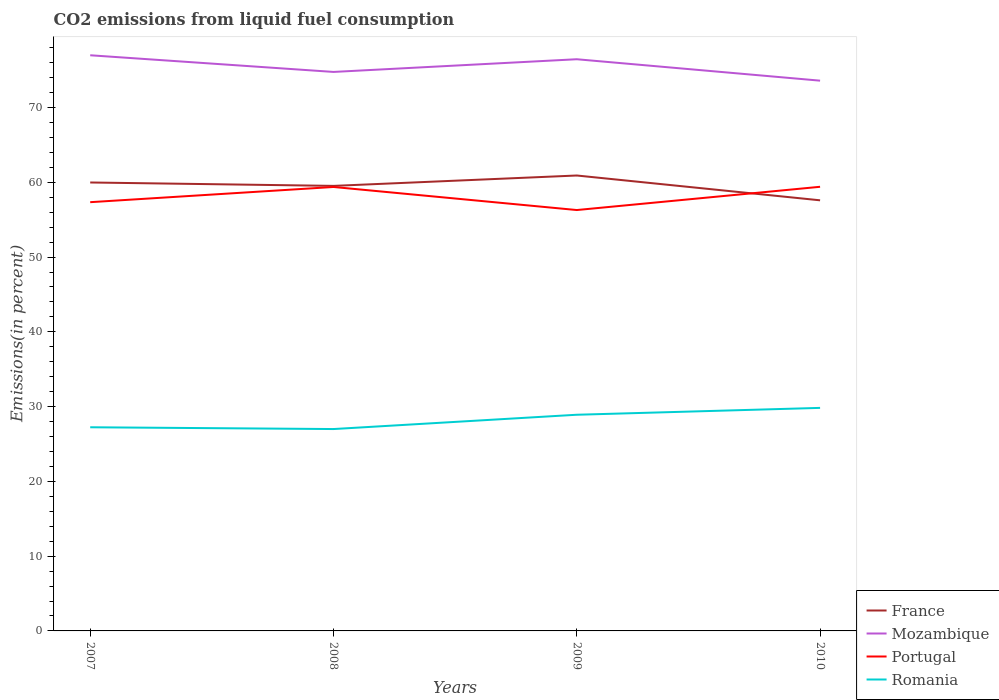How many different coloured lines are there?
Your answer should be compact. 4. Across all years, what is the maximum total CO2 emitted in Portugal?
Provide a short and direct response. 56.29. What is the total total CO2 emitted in Portugal in the graph?
Keep it short and to the point. -2.06. What is the difference between the highest and the second highest total CO2 emitted in France?
Your answer should be very brief. 3.32. What is the difference between the highest and the lowest total CO2 emitted in Portugal?
Keep it short and to the point. 2. Is the total CO2 emitted in Portugal strictly greater than the total CO2 emitted in Romania over the years?
Your answer should be compact. No. How many lines are there?
Your response must be concise. 4. What is the difference between two consecutive major ticks on the Y-axis?
Give a very brief answer. 10. Does the graph contain grids?
Make the answer very short. No. How are the legend labels stacked?
Provide a short and direct response. Vertical. What is the title of the graph?
Offer a very short reply. CO2 emissions from liquid fuel consumption. What is the label or title of the X-axis?
Offer a terse response. Years. What is the label or title of the Y-axis?
Make the answer very short. Emissions(in percent). What is the Emissions(in percent) in France in 2007?
Your answer should be compact. 59.98. What is the Emissions(in percent) of Mozambique in 2007?
Give a very brief answer. 76.99. What is the Emissions(in percent) in Portugal in 2007?
Ensure brevity in your answer.  57.34. What is the Emissions(in percent) in Romania in 2007?
Ensure brevity in your answer.  27.24. What is the Emissions(in percent) in France in 2008?
Your response must be concise. 59.52. What is the Emissions(in percent) of Mozambique in 2008?
Offer a terse response. 74.76. What is the Emissions(in percent) in Portugal in 2008?
Provide a short and direct response. 59.38. What is the Emissions(in percent) of Romania in 2008?
Offer a terse response. 27. What is the Emissions(in percent) of France in 2009?
Make the answer very short. 60.91. What is the Emissions(in percent) of Mozambique in 2009?
Provide a short and direct response. 76.46. What is the Emissions(in percent) in Portugal in 2009?
Keep it short and to the point. 56.29. What is the Emissions(in percent) of Romania in 2009?
Provide a succinct answer. 28.91. What is the Emissions(in percent) in France in 2010?
Provide a succinct answer. 57.59. What is the Emissions(in percent) of Mozambique in 2010?
Offer a very short reply. 73.6. What is the Emissions(in percent) in Portugal in 2010?
Make the answer very short. 59.4. What is the Emissions(in percent) in Romania in 2010?
Provide a short and direct response. 29.83. Across all years, what is the maximum Emissions(in percent) in France?
Provide a succinct answer. 60.91. Across all years, what is the maximum Emissions(in percent) in Mozambique?
Your answer should be compact. 76.99. Across all years, what is the maximum Emissions(in percent) in Portugal?
Ensure brevity in your answer.  59.4. Across all years, what is the maximum Emissions(in percent) in Romania?
Offer a very short reply. 29.83. Across all years, what is the minimum Emissions(in percent) of France?
Give a very brief answer. 57.59. Across all years, what is the minimum Emissions(in percent) of Mozambique?
Your response must be concise. 73.6. Across all years, what is the minimum Emissions(in percent) of Portugal?
Your response must be concise. 56.29. Across all years, what is the minimum Emissions(in percent) in Romania?
Keep it short and to the point. 27. What is the total Emissions(in percent) of France in the graph?
Provide a succinct answer. 238.01. What is the total Emissions(in percent) of Mozambique in the graph?
Ensure brevity in your answer.  301.82. What is the total Emissions(in percent) in Portugal in the graph?
Your response must be concise. 232.42. What is the total Emissions(in percent) of Romania in the graph?
Your answer should be compact. 112.98. What is the difference between the Emissions(in percent) in France in 2007 and that in 2008?
Your response must be concise. 0.45. What is the difference between the Emissions(in percent) of Mozambique in 2007 and that in 2008?
Provide a short and direct response. 2.23. What is the difference between the Emissions(in percent) in Portugal in 2007 and that in 2008?
Keep it short and to the point. -2.03. What is the difference between the Emissions(in percent) of Romania in 2007 and that in 2008?
Offer a very short reply. 0.24. What is the difference between the Emissions(in percent) of France in 2007 and that in 2009?
Your response must be concise. -0.93. What is the difference between the Emissions(in percent) of Mozambique in 2007 and that in 2009?
Your response must be concise. 0.53. What is the difference between the Emissions(in percent) of Portugal in 2007 and that in 2009?
Provide a succinct answer. 1.05. What is the difference between the Emissions(in percent) in Romania in 2007 and that in 2009?
Provide a succinct answer. -1.67. What is the difference between the Emissions(in percent) of France in 2007 and that in 2010?
Your response must be concise. 2.38. What is the difference between the Emissions(in percent) of Mozambique in 2007 and that in 2010?
Keep it short and to the point. 3.4. What is the difference between the Emissions(in percent) of Portugal in 2007 and that in 2010?
Provide a succinct answer. -2.06. What is the difference between the Emissions(in percent) in Romania in 2007 and that in 2010?
Your response must be concise. -2.59. What is the difference between the Emissions(in percent) in France in 2008 and that in 2009?
Ensure brevity in your answer.  -1.39. What is the difference between the Emissions(in percent) in Mozambique in 2008 and that in 2009?
Ensure brevity in your answer.  -1.7. What is the difference between the Emissions(in percent) of Portugal in 2008 and that in 2009?
Give a very brief answer. 3.09. What is the difference between the Emissions(in percent) in Romania in 2008 and that in 2009?
Provide a short and direct response. -1.91. What is the difference between the Emissions(in percent) of France in 2008 and that in 2010?
Ensure brevity in your answer.  1.93. What is the difference between the Emissions(in percent) in Mozambique in 2008 and that in 2010?
Make the answer very short. 1.17. What is the difference between the Emissions(in percent) of Portugal in 2008 and that in 2010?
Give a very brief answer. -0.02. What is the difference between the Emissions(in percent) in Romania in 2008 and that in 2010?
Offer a very short reply. -2.83. What is the difference between the Emissions(in percent) of France in 2009 and that in 2010?
Your answer should be very brief. 3.32. What is the difference between the Emissions(in percent) of Mozambique in 2009 and that in 2010?
Give a very brief answer. 2.87. What is the difference between the Emissions(in percent) in Portugal in 2009 and that in 2010?
Provide a short and direct response. -3.11. What is the difference between the Emissions(in percent) in Romania in 2009 and that in 2010?
Your response must be concise. -0.92. What is the difference between the Emissions(in percent) in France in 2007 and the Emissions(in percent) in Mozambique in 2008?
Offer a terse response. -14.79. What is the difference between the Emissions(in percent) of France in 2007 and the Emissions(in percent) of Portugal in 2008?
Offer a terse response. 0.6. What is the difference between the Emissions(in percent) of France in 2007 and the Emissions(in percent) of Romania in 2008?
Offer a terse response. 32.98. What is the difference between the Emissions(in percent) in Mozambique in 2007 and the Emissions(in percent) in Portugal in 2008?
Your answer should be very brief. 17.62. What is the difference between the Emissions(in percent) of Mozambique in 2007 and the Emissions(in percent) of Romania in 2008?
Provide a short and direct response. 49.99. What is the difference between the Emissions(in percent) in Portugal in 2007 and the Emissions(in percent) in Romania in 2008?
Offer a very short reply. 30.34. What is the difference between the Emissions(in percent) in France in 2007 and the Emissions(in percent) in Mozambique in 2009?
Offer a terse response. -16.48. What is the difference between the Emissions(in percent) in France in 2007 and the Emissions(in percent) in Portugal in 2009?
Provide a succinct answer. 3.69. What is the difference between the Emissions(in percent) in France in 2007 and the Emissions(in percent) in Romania in 2009?
Provide a succinct answer. 31.06. What is the difference between the Emissions(in percent) in Mozambique in 2007 and the Emissions(in percent) in Portugal in 2009?
Provide a succinct answer. 20.7. What is the difference between the Emissions(in percent) in Mozambique in 2007 and the Emissions(in percent) in Romania in 2009?
Your answer should be compact. 48.08. What is the difference between the Emissions(in percent) of Portugal in 2007 and the Emissions(in percent) of Romania in 2009?
Give a very brief answer. 28.43. What is the difference between the Emissions(in percent) of France in 2007 and the Emissions(in percent) of Mozambique in 2010?
Offer a very short reply. -13.62. What is the difference between the Emissions(in percent) in France in 2007 and the Emissions(in percent) in Portugal in 2010?
Ensure brevity in your answer.  0.58. What is the difference between the Emissions(in percent) in France in 2007 and the Emissions(in percent) in Romania in 2010?
Your answer should be very brief. 30.15. What is the difference between the Emissions(in percent) in Mozambique in 2007 and the Emissions(in percent) in Portugal in 2010?
Offer a terse response. 17.59. What is the difference between the Emissions(in percent) in Mozambique in 2007 and the Emissions(in percent) in Romania in 2010?
Offer a very short reply. 47.16. What is the difference between the Emissions(in percent) of Portugal in 2007 and the Emissions(in percent) of Romania in 2010?
Ensure brevity in your answer.  27.51. What is the difference between the Emissions(in percent) of France in 2008 and the Emissions(in percent) of Mozambique in 2009?
Keep it short and to the point. -16.94. What is the difference between the Emissions(in percent) in France in 2008 and the Emissions(in percent) in Portugal in 2009?
Provide a succinct answer. 3.23. What is the difference between the Emissions(in percent) in France in 2008 and the Emissions(in percent) in Romania in 2009?
Offer a very short reply. 30.61. What is the difference between the Emissions(in percent) in Mozambique in 2008 and the Emissions(in percent) in Portugal in 2009?
Offer a very short reply. 18.47. What is the difference between the Emissions(in percent) in Mozambique in 2008 and the Emissions(in percent) in Romania in 2009?
Your answer should be compact. 45.85. What is the difference between the Emissions(in percent) of Portugal in 2008 and the Emissions(in percent) of Romania in 2009?
Offer a terse response. 30.46. What is the difference between the Emissions(in percent) in France in 2008 and the Emissions(in percent) in Mozambique in 2010?
Ensure brevity in your answer.  -14.07. What is the difference between the Emissions(in percent) in France in 2008 and the Emissions(in percent) in Portugal in 2010?
Offer a very short reply. 0.12. What is the difference between the Emissions(in percent) in France in 2008 and the Emissions(in percent) in Romania in 2010?
Offer a very short reply. 29.69. What is the difference between the Emissions(in percent) of Mozambique in 2008 and the Emissions(in percent) of Portugal in 2010?
Offer a very short reply. 15.36. What is the difference between the Emissions(in percent) in Mozambique in 2008 and the Emissions(in percent) in Romania in 2010?
Ensure brevity in your answer.  44.93. What is the difference between the Emissions(in percent) of Portugal in 2008 and the Emissions(in percent) of Romania in 2010?
Give a very brief answer. 29.55. What is the difference between the Emissions(in percent) of France in 2009 and the Emissions(in percent) of Mozambique in 2010?
Offer a terse response. -12.68. What is the difference between the Emissions(in percent) in France in 2009 and the Emissions(in percent) in Portugal in 2010?
Offer a terse response. 1.51. What is the difference between the Emissions(in percent) in France in 2009 and the Emissions(in percent) in Romania in 2010?
Ensure brevity in your answer.  31.08. What is the difference between the Emissions(in percent) of Mozambique in 2009 and the Emissions(in percent) of Portugal in 2010?
Your response must be concise. 17.06. What is the difference between the Emissions(in percent) in Mozambique in 2009 and the Emissions(in percent) in Romania in 2010?
Offer a very short reply. 46.63. What is the difference between the Emissions(in percent) in Portugal in 2009 and the Emissions(in percent) in Romania in 2010?
Offer a terse response. 26.46. What is the average Emissions(in percent) of France per year?
Your answer should be compact. 59.5. What is the average Emissions(in percent) of Mozambique per year?
Offer a very short reply. 75.45. What is the average Emissions(in percent) in Portugal per year?
Your answer should be very brief. 58.1. What is the average Emissions(in percent) of Romania per year?
Make the answer very short. 28.25. In the year 2007, what is the difference between the Emissions(in percent) in France and Emissions(in percent) in Mozambique?
Your response must be concise. -17.02. In the year 2007, what is the difference between the Emissions(in percent) in France and Emissions(in percent) in Portugal?
Ensure brevity in your answer.  2.63. In the year 2007, what is the difference between the Emissions(in percent) of France and Emissions(in percent) of Romania?
Offer a terse response. 32.74. In the year 2007, what is the difference between the Emissions(in percent) of Mozambique and Emissions(in percent) of Portugal?
Your response must be concise. 19.65. In the year 2007, what is the difference between the Emissions(in percent) of Mozambique and Emissions(in percent) of Romania?
Make the answer very short. 49.75. In the year 2007, what is the difference between the Emissions(in percent) of Portugal and Emissions(in percent) of Romania?
Keep it short and to the point. 30.11. In the year 2008, what is the difference between the Emissions(in percent) of France and Emissions(in percent) of Mozambique?
Ensure brevity in your answer.  -15.24. In the year 2008, what is the difference between the Emissions(in percent) of France and Emissions(in percent) of Portugal?
Ensure brevity in your answer.  0.14. In the year 2008, what is the difference between the Emissions(in percent) in France and Emissions(in percent) in Romania?
Your answer should be compact. 32.52. In the year 2008, what is the difference between the Emissions(in percent) of Mozambique and Emissions(in percent) of Portugal?
Offer a very short reply. 15.39. In the year 2008, what is the difference between the Emissions(in percent) in Mozambique and Emissions(in percent) in Romania?
Provide a short and direct response. 47.77. In the year 2008, what is the difference between the Emissions(in percent) of Portugal and Emissions(in percent) of Romania?
Your response must be concise. 32.38. In the year 2009, what is the difference between the Emissions(in percent) of France and Emissions(in percent) of Mozambique?
Ensure brevity in your answer.  -15.55. In the year 2009, what is the difference between the Emissions(in percent) of France and Emissions(in percent) of Portugal?
Your response must be concise. 4.62. In the year 2009, what is the difference between the Emissions(in percent) in France and Emissions(in percent) in Romania?
Your response must be concise. 32. In the year 2009, what is the difference between the Emissions(in percent) in Mozambique and Emissions(in percent) in Portugal?
Provide a short and direct response. 20.17. In the year 2009, what is the difference between the Emissions(in percent) of Mozambique and Emissions(in percent) of Romania?
Offer a terse response. 47.55. In the year 2009, what is the difference between the Emissions(in percent) of Portugal and Emissions(in percent) of Romania?
Your answer should be very brief. 27.38. In the year 2010, what is the difference between the Emissions(in percent) of France and Emissions(in percent) of Mozambique?
Provide a succinct answer. -16. In the year 2010, what is the difference between the Emissions(in percent) in France and Emissions(in percent) in Portugal?
Your answer should be very brief. -1.81. In the year 2010, what is the difference between the Emissions(in percent) in France and Emissions(in percent) in Romania?
Give a very brief answer. 27.76. In the year 2010, what is the difference between the Emissions(in percent) of Mozambique and Emissions(in percent) of Portugal?
Provide a short and direct response. 14.19. In the year 2010, what is the difference between the Emissions(in percent) in Mozambique and Emissions(in percent) in Romania?
Your response must be concise. 43.77. In the year 2010, what is the difference between the Emissions(in percent) in Portugal and Emissions(in percent) in Romania?
Give a very brief answer. 29.57. What is the ratio of the Emissions(in percent) in France in 2007 to that in 2008?
Provide a short and direct response. 1.01. What is the ratio of the Emissions(in percent) in Mozambique in 2007 to that in 2008?
Give a very brief answer. 1.03. What is the ratio of the Emissions(in percent) in Portugal in 2007 to that in 2008?
Give a very brief answer. 0.97. What is the ratio of the Emissions(in percent) in Romania in 2007 to that in 2008?
Your answer should be compact. 1.01. What is the ratio of the Emissions(in percent) of France in 2007 to that in 2009?
Ensure brevity in your answer.  0.98. What is the ratio of the Emissions(in percent) in Portugal in 2007 to that in 2009?
Keep it short and to the point. 1.02. What is the ratio of the Emissions(in percent) in Romania in 2007 to that in 2009?
Offer a terse response. 0.94. What is the ratio of the Emissions(in percent) of France in 2007 to that in 2010?
Your answer should be very brief. 1.04. What is the ratio of the Emissions(in percent) in Mozambique in 2007 to that in 2010?
Provide a succinct answer. 1.05. What is the ratio of the Emissions(in percent) of Portugal in 2007 to that in 2010?
Your answer should be very brief. 0.97. What is the ratio of the Emissions(in percent) of Romania in 2007 to that in 2010?
Your answer should be very brief. 0.91. What is the ratio of the Emissions(in percent) of France in 2008 to that in 2009?
Offer a terse response. 0.98. What is the ratio of the Emissions(in percent) in Mozambique in 2008 to that in 2009?
Your answer should be very brief. 0.98. What is the ratio of the Emissions(in percent) of Portugal in 2008 to that in 2009?
Provide a short and direct response. 1.05. What is the ratio of the Emissions(in percent) of Romania in 2008 to that in 2009?
Your answer should be compact. 0.93. What is the ratio of the Emissions(in percent) of France in 2008 to that in 2010?
Provide a succinct answer. 1.03. What is the ratio of the Emissions(in percent) in Mozambique in 2008 to that in 2010?
Make the answer very short. 1.02. What is the ratio of the Emissions(in percent) of Portugal in 2008 to that in 2010?
Keep it short and to the point. 1. What is the ratio of the Emissions(in percent) of Romania in 2008 to that in 2010?
Your response must be concise. 0.91. What is the ratio of the Emissions(in percent) of France in 2009 to that in 2010?
Make the answer very short. 1.06. What is the ratio of the Emissions(in percent) in Mozambique in 2009 to that in 2010?
Give a very brief answer. 1.04. What is the ratio of the Emissions(in percent) in Portugal in 2009 to that in 2010?
Provide a short and direct response. 0.95. What is the ratio of the Emissions(in percent) in Romania in 2009 to that in 2010?
Offer a terse response. 0.97. What is the difference between the highest and the second highest Emissions(in percent) of France?
Give a very brief answer. 0.93. What is the difference between the highest and the second highest Emissions(in percent) of Mozambique?
Keep it short and to the point. 0.53. What is the difference between the highest and the second highest Emissions(in percent) of Portugal?
Make the answer very short. 0.02. What is the difference between the highest and the second highest Emissions(in percent) of Romania?
Your answer should be compact. 0.92. What is the difference between the highest and the lowest Emissions(in percent) of France?
Keep it short and to the point. 3.32. What is the difference between the highest and the lowest Emissions(in percent) of Mozambique?
Provide a short and direct response. 3.4. What is the difference between the highest and the lowest Emissions(in percent) in Portugal?
Offer a terse response. 3.11. What is the difference between the highest and the lowest Emissions(in percent) in Romania?
Provide a succinct answer. 2.83. 